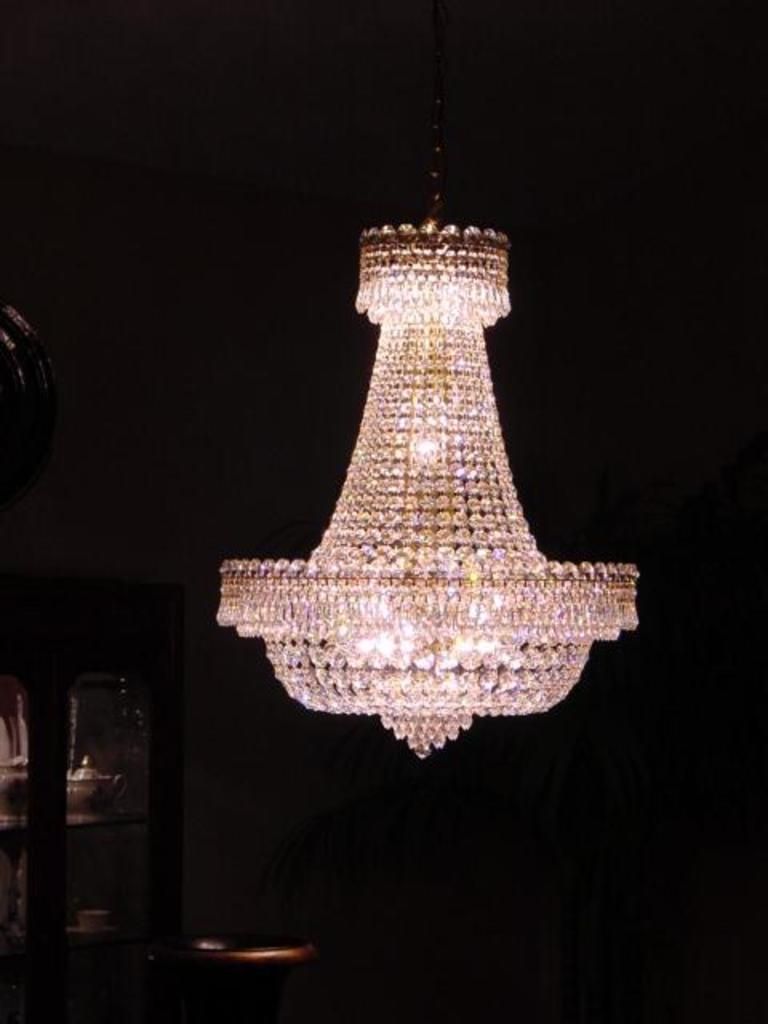What is the main object in the center of the image? There is a chandelier in the center of the image. Where is the cupboard located in the image? The cupboard is in the bottom left corner of the image. What can be found inside the cupboard? The cupboard contains objects. What type of plot is the crook planning in the image? There is no crook or plot present in the image; it features a chandelier and a cupboard. How many members are on the committee in the image? There is no committee present in the image. 